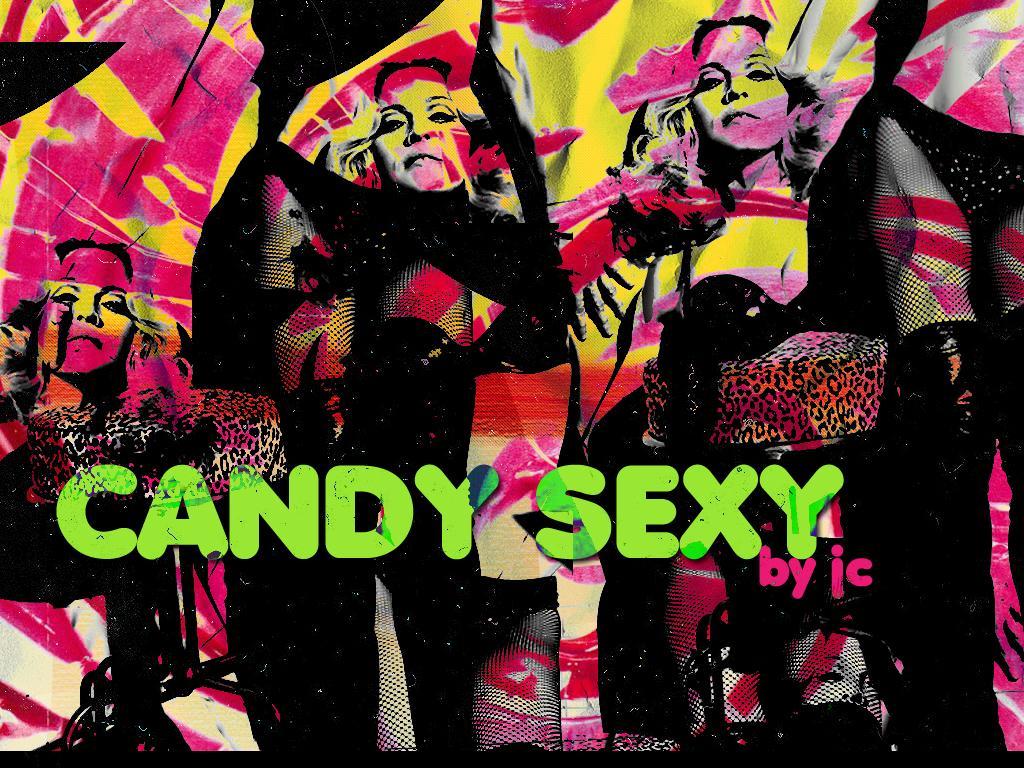In one or two sentences, can you explain what this image depicts? In the center of the image there are depictions of women. There is some text. 